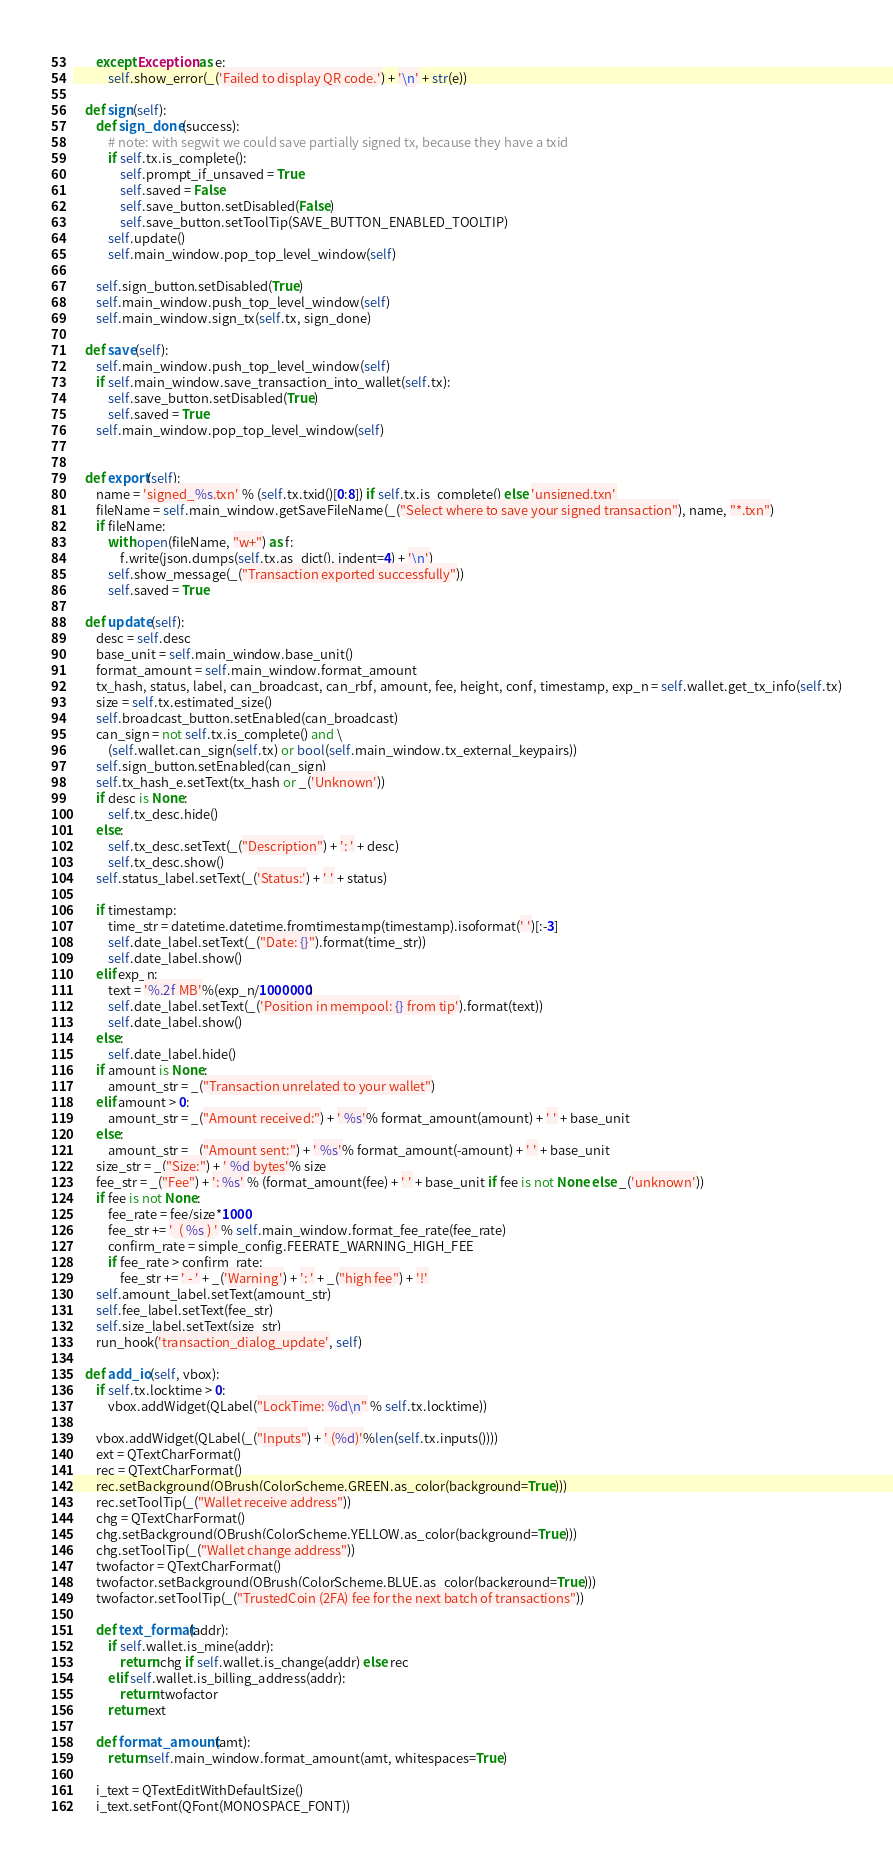Convert code to text. <code><loc_0><loc_0><loc_500><loc_500><_Python_>        except Exception as e:
            self.show_error(_('Failed to display QR code.') + '\n' + str(e))

    def sign(self):
        def sign_done(success):
            # note: with segwit we could save partially signed tx, because they have a txid
            if self.tx.is_complete():
                self.prompt_if_unsaved = True
                self.saved = False
                self.save_button.setDisabled(False)
                self.save_button.setToolTip(SAVE_BUTTON_ENABLED_TOOLTIP)
            self.update()
            self.main_window.pop_top_level_window(self)

        self.sign_button.setDisabled(True)
        self.main_window.push_top_level_window(self)
        self.main_window.sign_tx(self.tx, sign_done)

    def save(self):
        self.main_window.push_top_level_window(self)
        if self.main_window.save_transaction_into_wallet(self.tx):
            self.save_button.setDisabled(True)
            self.saved = True
        self.main_window.pop_top_level_window(self)


    def export(self):
        name = 'signed_%s.txn' % (self.tx.txid()[0:8]) if self.tx.is_complete() else 'unsigned.txn'
        fileName = self.main_window.getSaveFileName(_("Select where to save your signed transaction"), name, "*.txn")
        if fileName:
            with open(fileName, "w+") as f:
                f.write(json.dumps(self.tx.as_dict(), indent=4) + '\n')
            self.show_message(_("Transaction exported successfully"))
            self.saved = True

    def update(self):
        desc = self.desc
        base_unit = self.main_window.base_unit()
        format_amount = self.main_window.format_amount
        tx_hash, status, label, can_broadcast, can_rbf, amount, fee, height, conf, timestamp, exp_n = self.wallet.get_tx_info(self.tx)
        size = self.tx.estimated_size()
        self.broadcast_button.setEnabled(can_broadcast)
        can_sign = not self.tx.is_complete() and \
            (self.wallet.can_sign(self.tx) or bool(self.main_window.tx_external_keypairs))
        self.sign_button.setEnabled(can_sign)
        self.tx_hash_e.setText(tx_hash or _('Unknown'))
        if desc is None:
            self.tx_desc.hide()
        else:
            self.tx_desc.setText(_("Description") + ': ' + desc)
            self.tx_desc.show()
        self.status_label.setText(_('Status:') + ' ' + status)

        if timestamp:
            time_str = datetime.datetime.fromtimestamp(timestamp).isoformat(' ')[:-3]
            self.date_label.setText(_("Date: {}").format(time_str))
            self.date_label.show()
        elif exp_n:
            text = '%.2f MB'%(exp_n/1000000)
            self.date_label.setText(_('Position in mempool: {} from tip').format(text))
            self.date_label.show()
        else:
            self.date_label.hide()
        if amount is None:
            amount_str = _("Transaction unrelated to your wallet")
        elif amount > 0:
            amount_str = _("Amount received:") + ' %s'% format_amount(amount) + ' ' + base_unit
        else:
            amount_str = _("Amount sent:") + ' %s'% format_amount(-amount) + ' ' + base_unit
        size_str = _("Size:") + ' %d bytes'% size
        fee_str = _("Fee") + ': %s' % (format_amount(fee) + ' ' + base_unit if fee is not None else _('unknown'))
        if fee is not None:
            fee_rate = fee/size*1000
            fee_str += '  ( %s ) ' % self.main_window.format_fee_rate(fee_rate)
            confirm_rate = simple_config.FEERATE_WARNING_HIGH_FEE
            if fee_rate > confirm_rate:
                fee_str += ' - ' + _('Warning') + ': ' + _("high fee") + '!'
        self.amount_label.setText(amount_str)
        self.fee_label.setText(fee_str)
        self.size_label.setText(size_str)
        run_hook('transaction_dialog_update', self)

    def add_io(self, vbox):
        if self.tx.locktime > 0:
            vbox.addWidget(QLabel("LockTime: %d\n" % self.tx.locktime))

        vbox.addWidget(QLabel(_("Inputs") + ' (%d)'%len(self.tx.inputs())))
        ext = QTextCharFormat()
        rec = QTextCharFormat()
        rec.setBackground(QBrush(ColorScheme.GREEN.as_color(background=True)))
        rec.setToolTip(_("Wallet receive address"))
        chg = QTextCharFormat()
        chg.setBackground(QBrush(ColorScheme.YELLOW.as_color(background=True)))
        chg.setToolTip(_("Wallet change address"))
        twofactor = QTextCharFormat()
        twofactor.setBackground(QBrush(ColorScheme.BLUE.as_color(background=True)))
        twofactor.setToolTip(_("TrustedCoin (2FA) fee for the next batch of transactions"))

        def text_format(addr):
            if self.wallet.is_mine(addr):
                return chg if self.wallet.is_change(addr) else rec
            elif self.wallet.is_billing_address(addr):
                return twofactor
            return ext

        def format_amount(amt):
            return self.main_window.format_amount(amt, whitespaces=True)

        i_text = QTextEditWithDefaultSize()
        i_text.setFont(QFont(MONOSPACE_FONT))</code> 